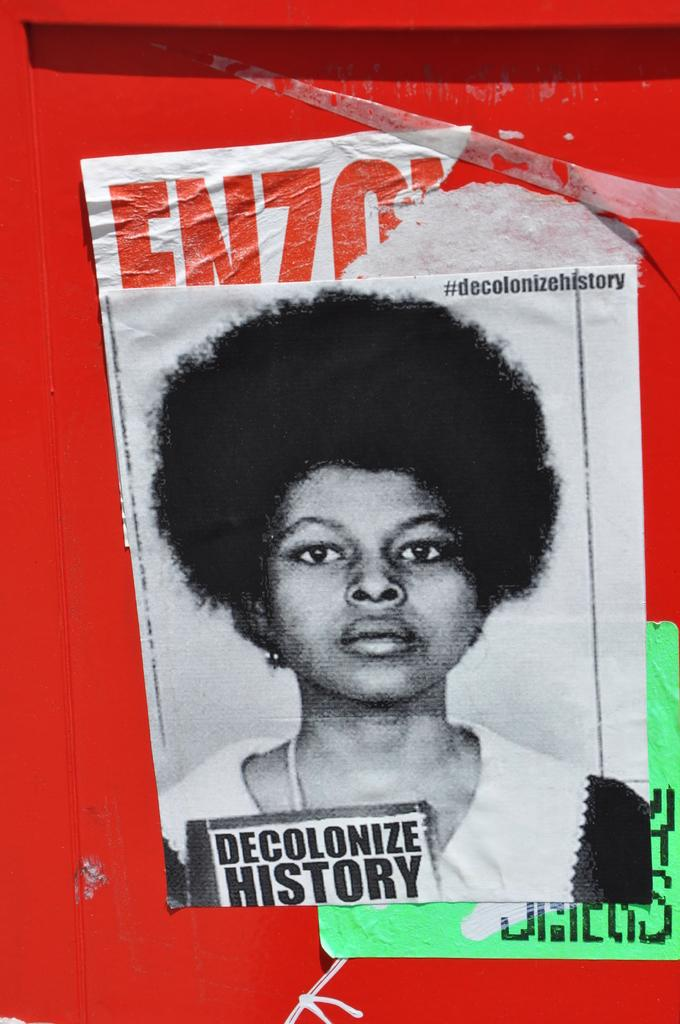What is featured on the poster in the image? There is a poster with text in the image. How is the poster displayed in the image? The poster is attached to a structure. What is the color of the structure in the image? The structure is in red color. How many tickets are available for the band's performance in the image? There is no band or tickets mentioned in the image; it only features a poster with text attached to a red structure. 